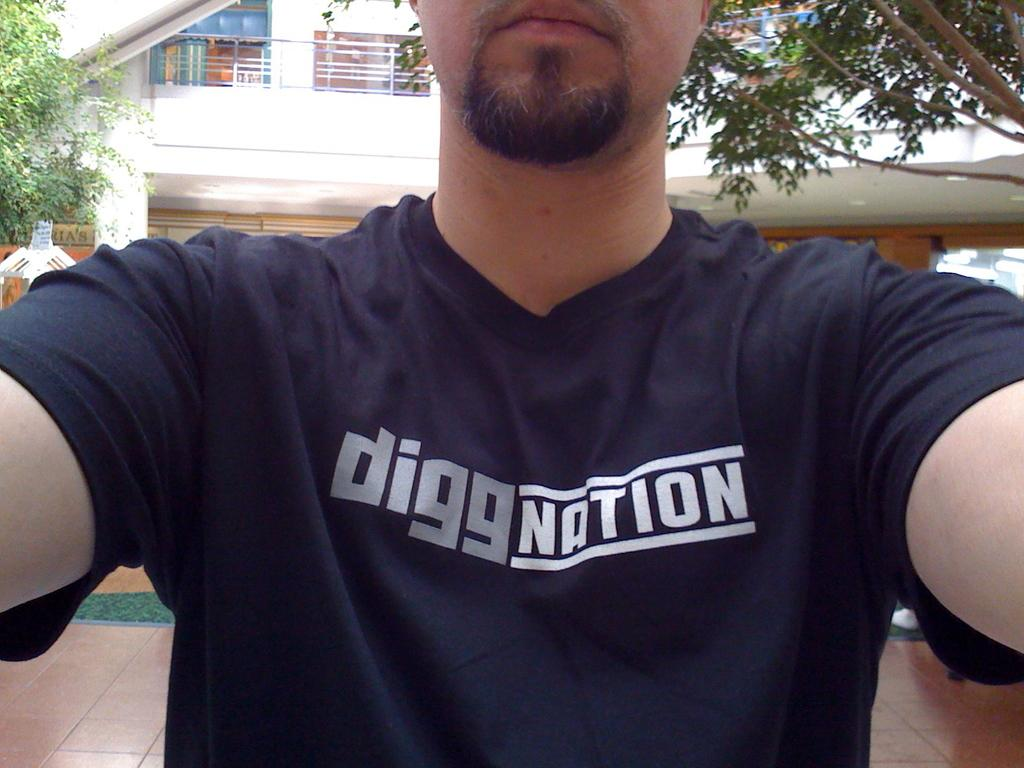<image>
Summarize the visual content of the image. A man takes a selfie while wearing a black "diggNation" shirt. 